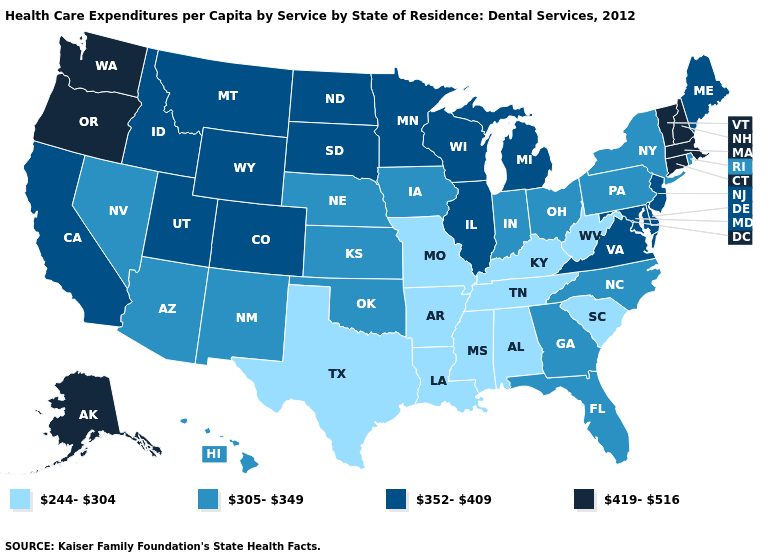Does Hawaii have a lower value than Missouri?
Keep it brief. No. Name the states that have a value in the range 419-516?
Quick response, please. Alaska, Connecticut, Massachusetts, New Hampshire, Oregon, Vermont, Washington. How many symbols are there in the legend?
Write a very short answer. 4. What is the value of Oklahoma?
Answer briefly. 305-349. How many symbols are there in the legend?
Quick response, please. 4. Among the states that border Florida , which have the lowest value?
Quick response, please. Alabama. Does Arkansas have the lowest value in the USA?
Answer briefly. Yes. Does New Jersey have the same value as Indiana?
Be succinct. No. Does Idaho have a lower value than California?
Write a very short answer. No. What is the lowest value in the USA?
Give a very brief answer. 244-304. What is the highest value in the USA?
Be succinct. 419-516. Does Mississippi have the highest value in the South?
Be succinct. No. Does Delaware have the highest value in the South?
Concise answer only. Yes. 